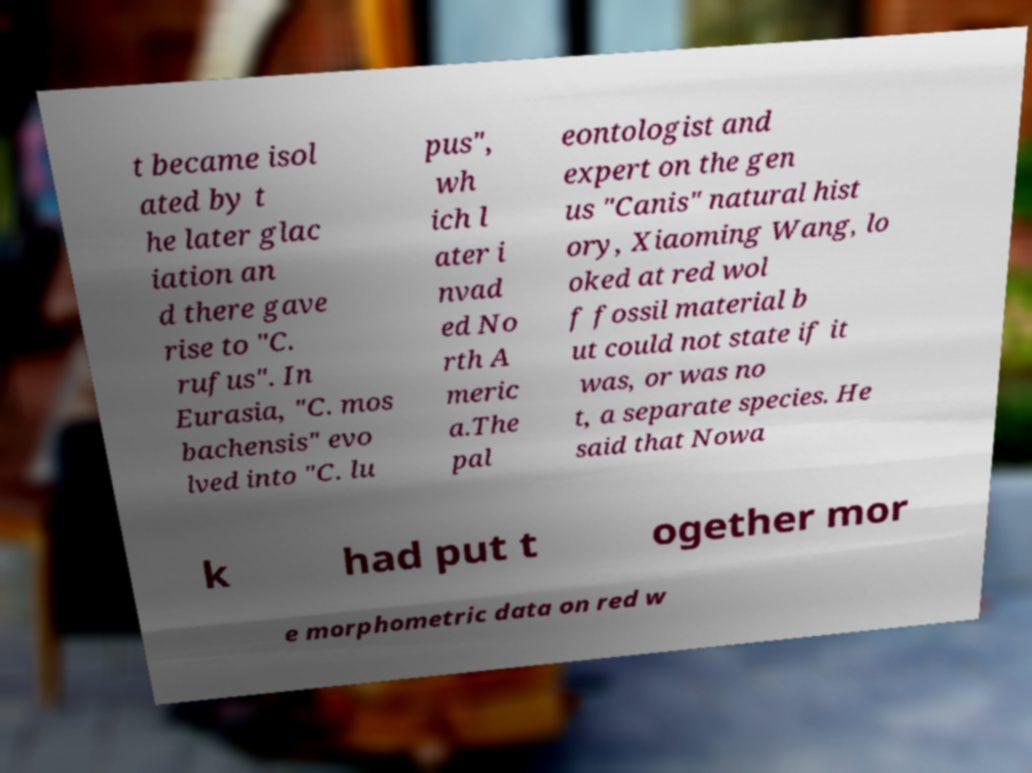There's text embedded in this image that I need extracted. Can you transcribe it verbatim? t became isol ated by t he later glac iation an d there gave rise to "C. rufus". In Eurasia, "C. mos bachensis" evo lved into "C. lu pus", wh ich l ater i nvad ed No rth A meric a.The pal eontologist and expert on the gen us "Canis" natural hist ory, Xiaoming Wang, lo oked at red wol f fossil material b ut could not state if it was, or was no t, a separate species. He said that Nowa k had put t ogether mor e morphometric data on red w 